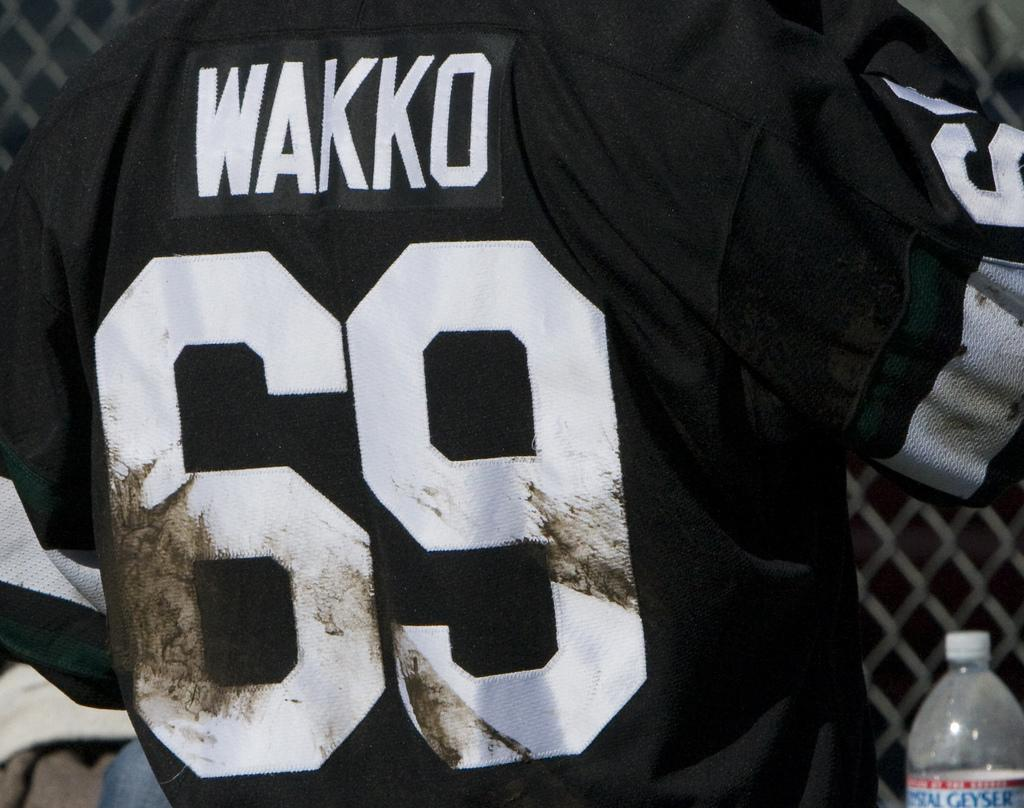<image>
Share a concise interpretation of the image provided. A sports player with the number 69 on his back. 